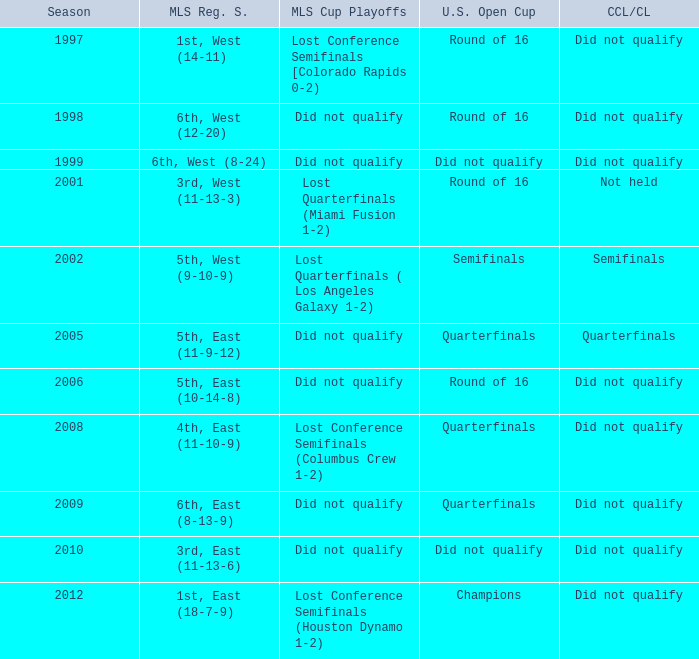When was the first season? 1997.0. 